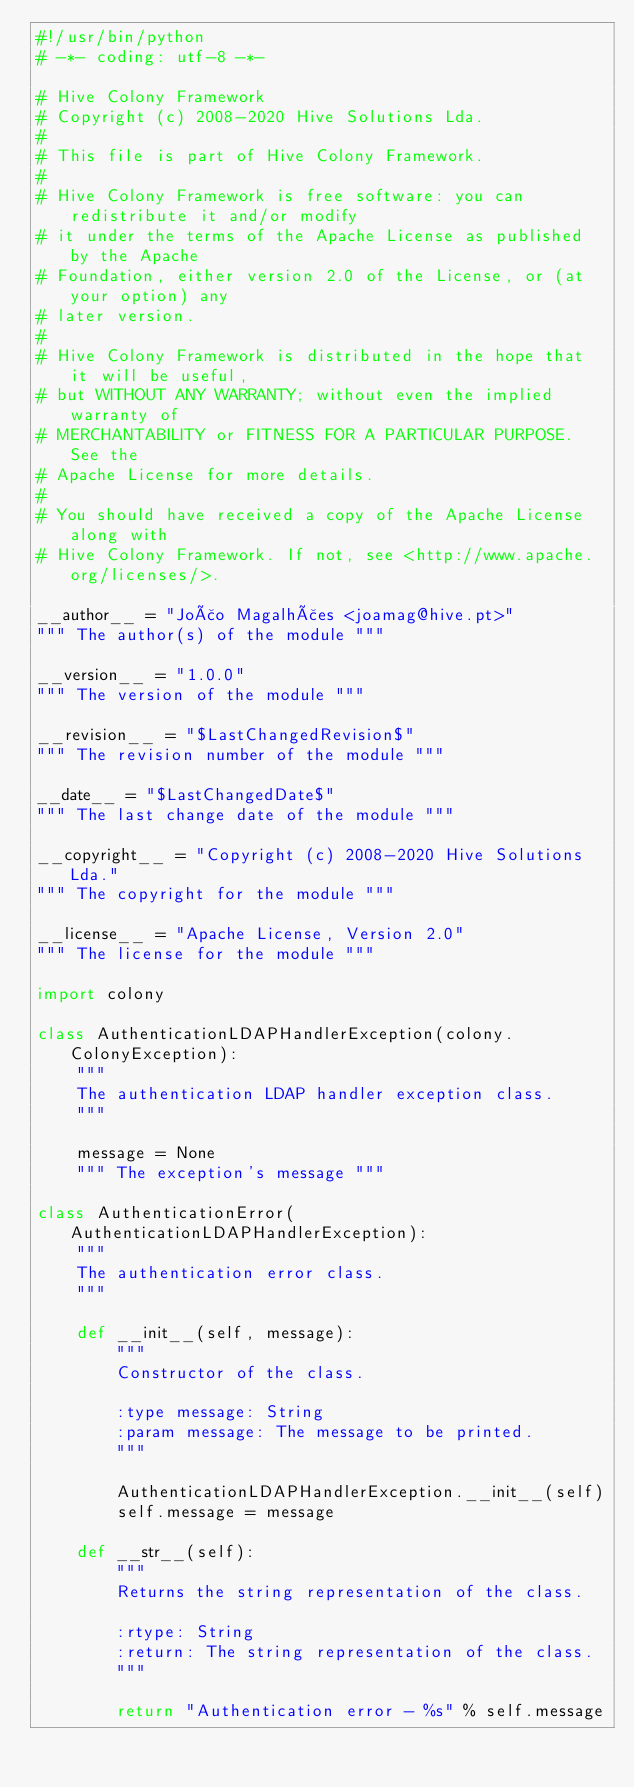<code> <loc_0><loc_0><loc_500><loc_500><_Python_>#!/usr/bin/python
# -*- coding: utf-8 -*-

# Hive Colony Framework
# Copyright (c) 2008-2020 Hive Solutions Lda.
#
# This file is part of Hive Colony Framework.
#
# Hive Colony Framework is free software: you can redistribute it and/or modify
# it under the terms of the Apache License as published by the Apache
# Foundation, either version 2.0 of the License, or (at your option) any
# later version.
#
# Hive Colony Framework is distributed in the hope that it will be useful,
# but WITHOUT ANY WARRANTY; without even the implied warranty of
# MERCHANTABILITY or FITNESS FOR A PARTICULAR PURPOSE. See the
# Apache License for more details.
#
# You should have received a copy of the Apache License along with
# Hive Colony Framework. If not, see <http://www.apache.org/licenses/>.

__author__ = "João Magalhães <joamag@hive.pt>"
""" The author(s) of the module """

__version__ = "1.0.0"
""" The version of the module """

__revision__ = "$LastChangedRevision$"
""" The revision number of the module """

__date__ = "$LastChangedDate$"
""" The last change date of the module """

__copyright__ = "Copyright (c) 2008-2020 Hive Solutions Lda."
""" The copyright for the module """

__license__ = "Apache License, Version 2.0"
""" The license for the module """

import colony

class AuthenticationLDAPHandlerException(colony.ColonyException):
    """
    The authentication LDAP handler exception class.
    """

    message = None
    """ The exception's message """

class AuthenticationError(AuthenticationLDAPHandlerException):
    """
    The authentication error class.
    """

    def __init__(self, message):
        """
        Constructor of the class.

        :type message: String
        :param message: The message to be printed.
        """

        AuthenticationLDAPHandlerException.__init__(self)
        self.message = message

    def __str__(self):
        """
        Returns the string representation of the class.

        :rtype: String
        :return: The string representation of the class.
        """

        return "Authentication error - %s" % self.message
</code> 